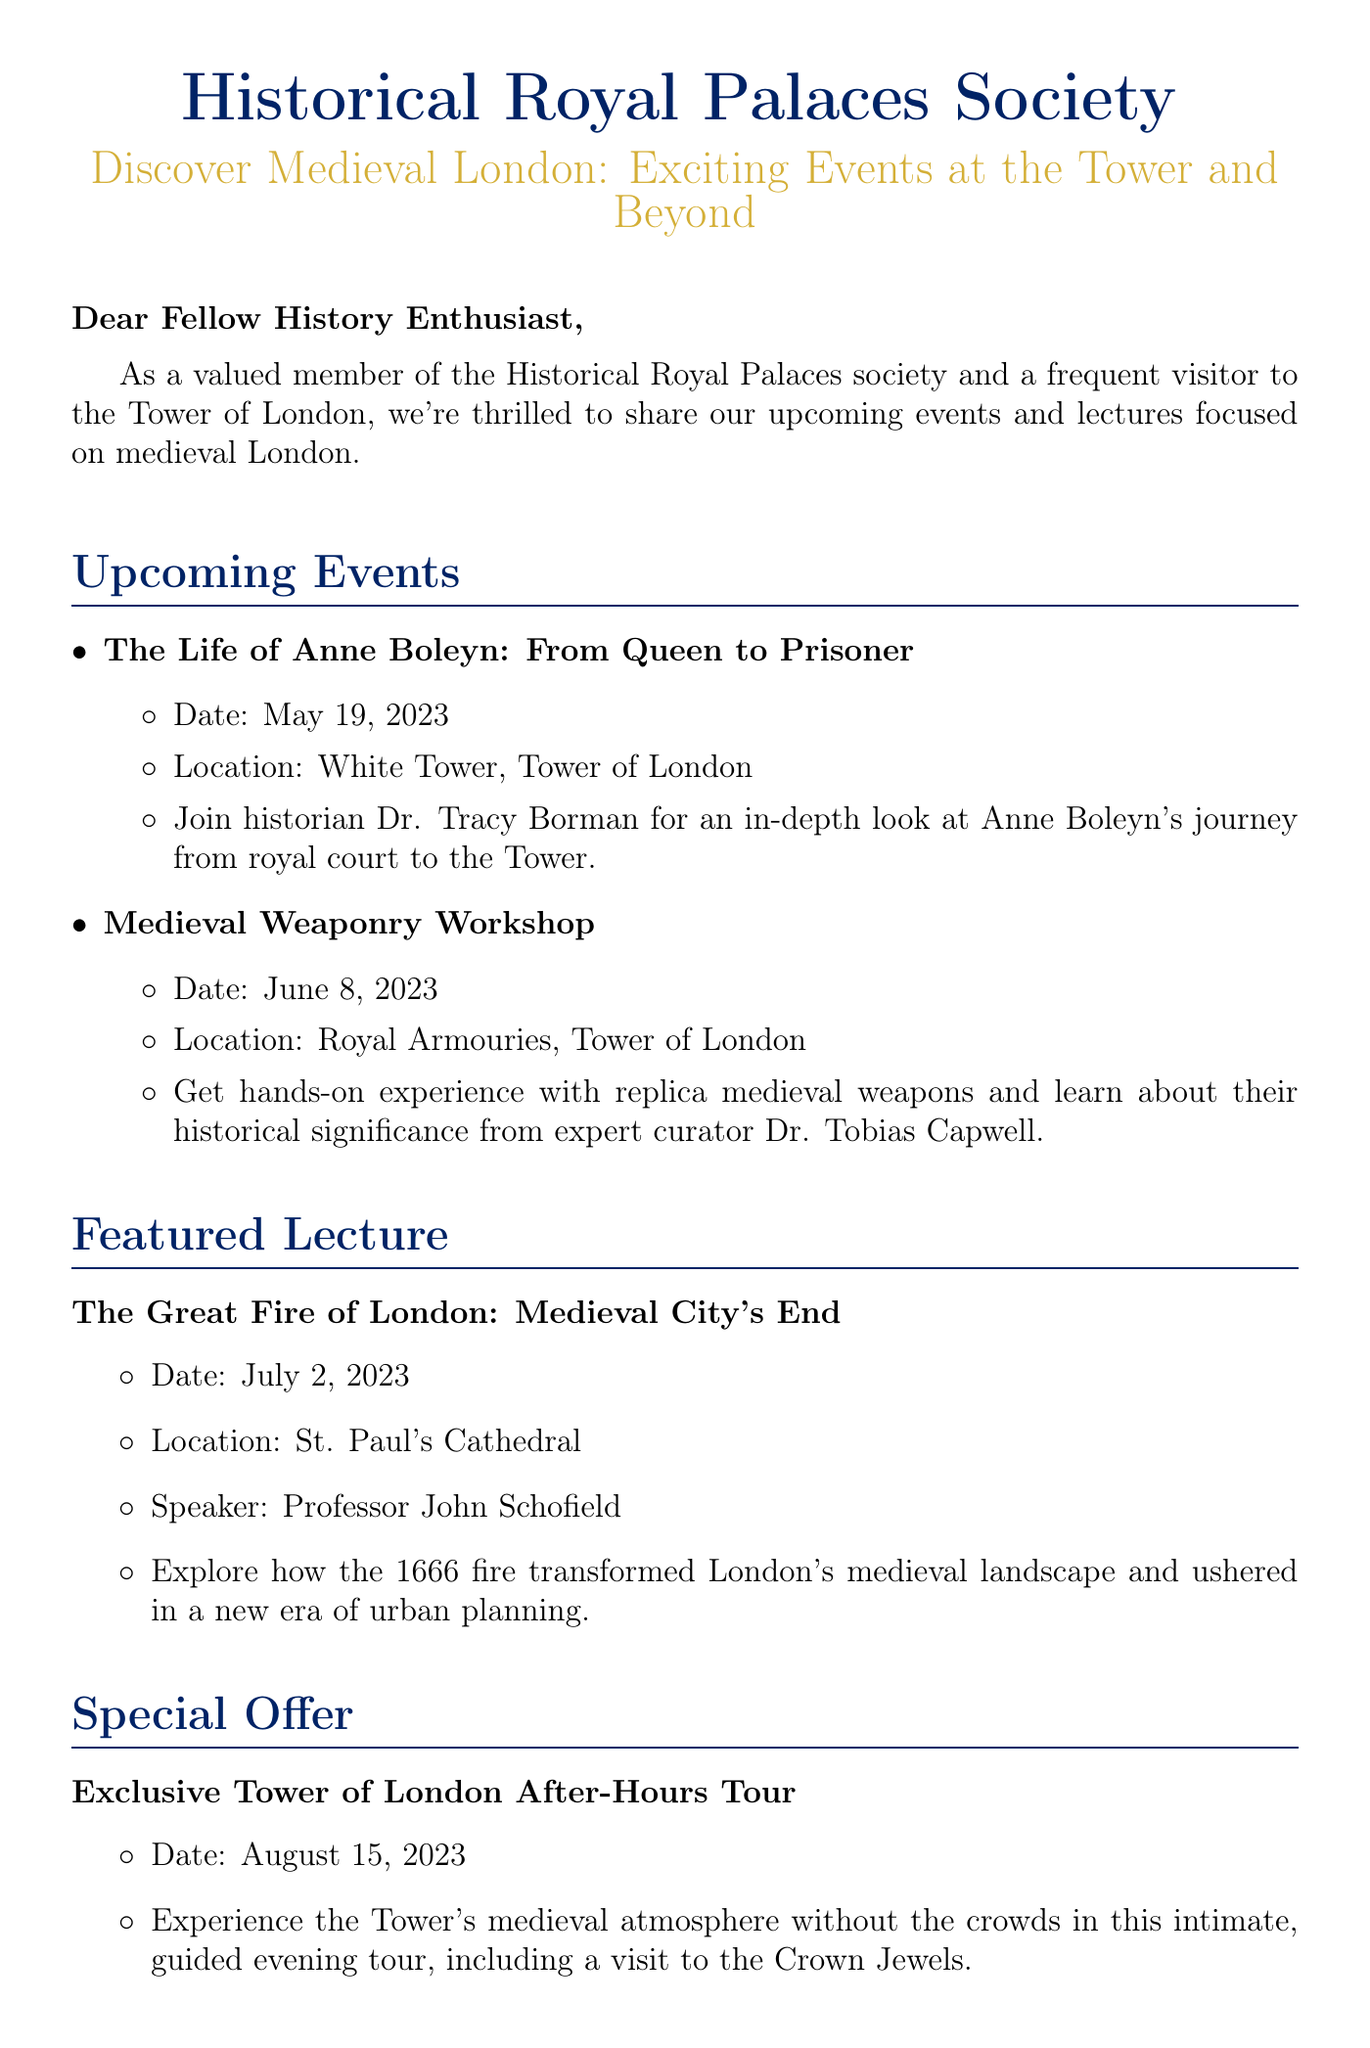What is the subject of the email? The subject is clearly stated at the beginning of the email, which outlines the main focus of the newsletter.
Answer: Discover Medieval London: Exciting Events at the Tower and Beyond Who is the speaker for the lecture on July 2, 2023? The document lists the speaker for the featured lecture, indicating who will present the topic.
Answer: Professor John Schofield What is the date of the Medieval Weaponry Workshop? The specific date for this event is included in the event details section of the document.
Answer: June 8, 2023 What location is associated with the Life of Anne Boleyn event? The document mentions the location for this particular event among other details about it.
Answer: White Tower, Tower of London What is offered as a special offer? The document highlights a unique opportunity presented to readers, which distinguishes it from regular events.
Answer: Exclusive Tower of London After-Hours Tour How many upcoming events are listed in the email? By counting the events presented, one can determine the total number of upcoming events highlighted in the newsletter.
Answer: 2 Which historical figure is discussed in the upcoming event on May 19, 2023? The document explicitly names the historical figure who is the focus of the event.
Answer: Anne Boleyn What is the main theme of the featured lecture? The title of the lecture provides insight into the topic that will be covered during the lecture.
Answer: The Great Fire of London: Medieval City's End When will the After-Hours Tour take place? The date for this special tour is explicitly mentioned in the corresponding section of the email.
Answer: August 15, 2023 